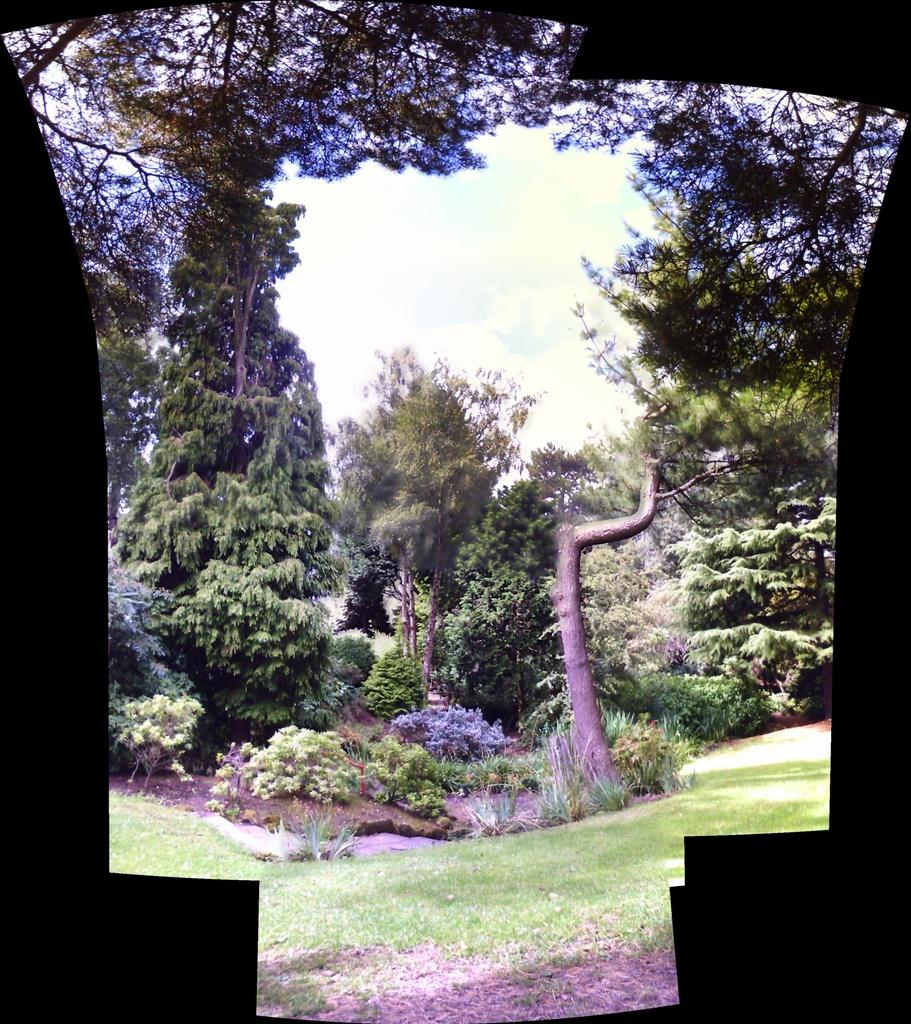What type of vegetation can be seen in the image? There are trees and plants in the image. What is the color of the trees and plants in the image? The trees and plants are green in color. What can be seen in the background of the image? The sky is visible in the background of the image. What are the colors of the sky in the image? The sky is blue and white in color. How many boys are lifting the governor in the image? There are no boys or governors present in the image; it features trees, plants, and a sky. 